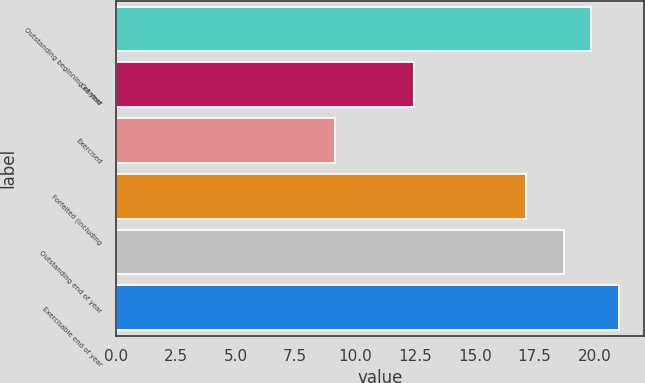Convert chart. <chart><loc_0><loc_0><loc_500><loc_500><bar_chart><fcel>Outstanding beginning of year<fcel>Granted<fcel>Exercised<fcel>Forfeited (including<fcel>Outstanding end of year<fcel>Exercisable end of year<nl><fcel>19.87<fcel>12.46<fcel>9.14<fcel>17.13<fcel>18.72<fcel>21.02<nl></chart> 